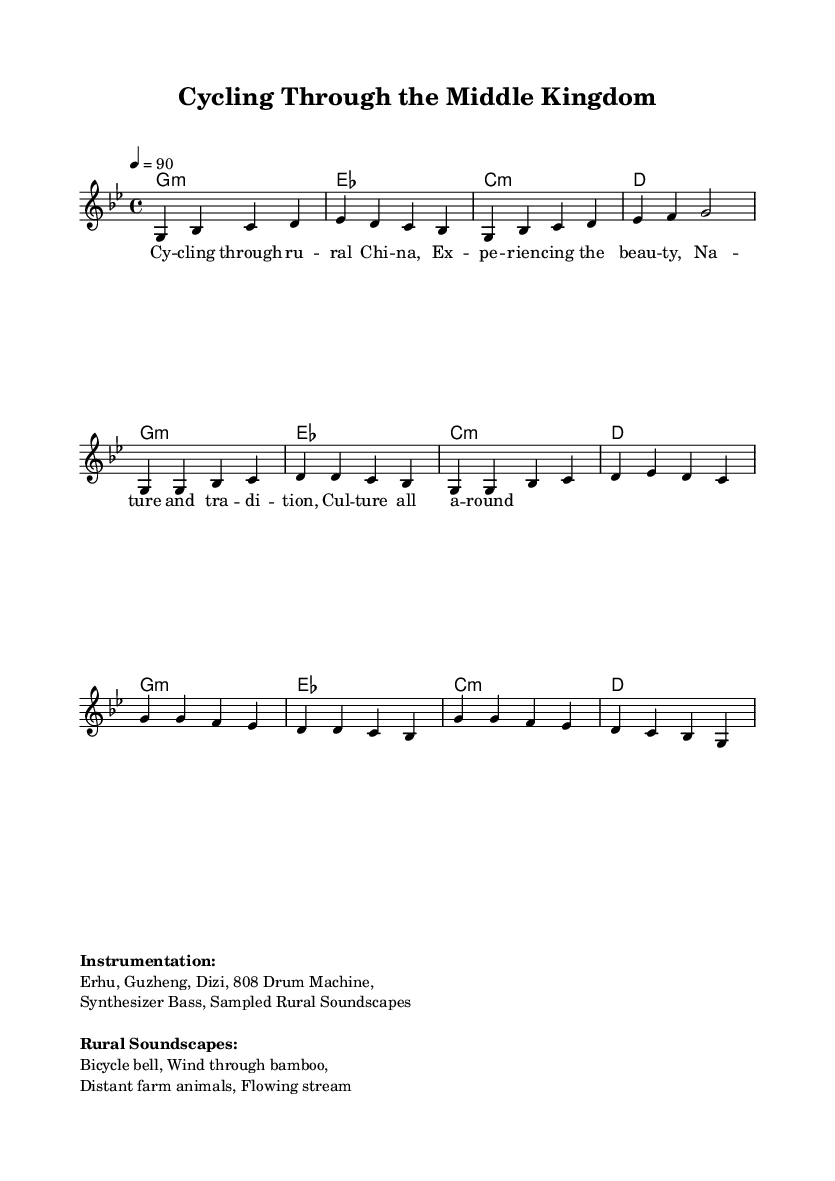What is the tempo of this music? The tempo is indicated as "4 = 90" in the score, which means the quarter note beats at 90 beats per minute.
Answer: 90 What is the key signature of this music? The key signature is denoted by the "g" before "minor," indicating the piece is in G minor, which has two flats.
Answer: G minor What instruments are featured in this piece? The instrumentation is listed under the markup section, which includes Erhu, Guzheng, Dizi, 808 Drum Machine, Synthesizer Bass, and Sampled Rural Soundscapes.
Answer: Erhu, Guzheng, Dizi, 808 Drum Machine, Synthesizer Bass, Sampled Rural Soundscapes How many measures are in the intro section? The intro section has four measures, as seen in the melody part where there are four groups of notes.
Answer: 4 What type of soundscapes are incorporated into this music? The rural soundscapes mentioned in the markup include a bicycle bell, wind through bamboo, distant farm animals, and a flowing stream, which blend into the musical atmosphere.
Answer: Bicycle bell, Wind through bamboo, Distant farm animals, Flowing stream What is the time signature used in this piece? The time signature is indicated as "4/4," which means there are four beats per measure, with each quarter note representing one beat.
Answer: 4/4 What genre does this music belong to? The music is described as "Fusion rap incorporating traditional Chinese instruments" which indicates that it blends elements of rap with traditional sounds.
Answer: Fusion rap 